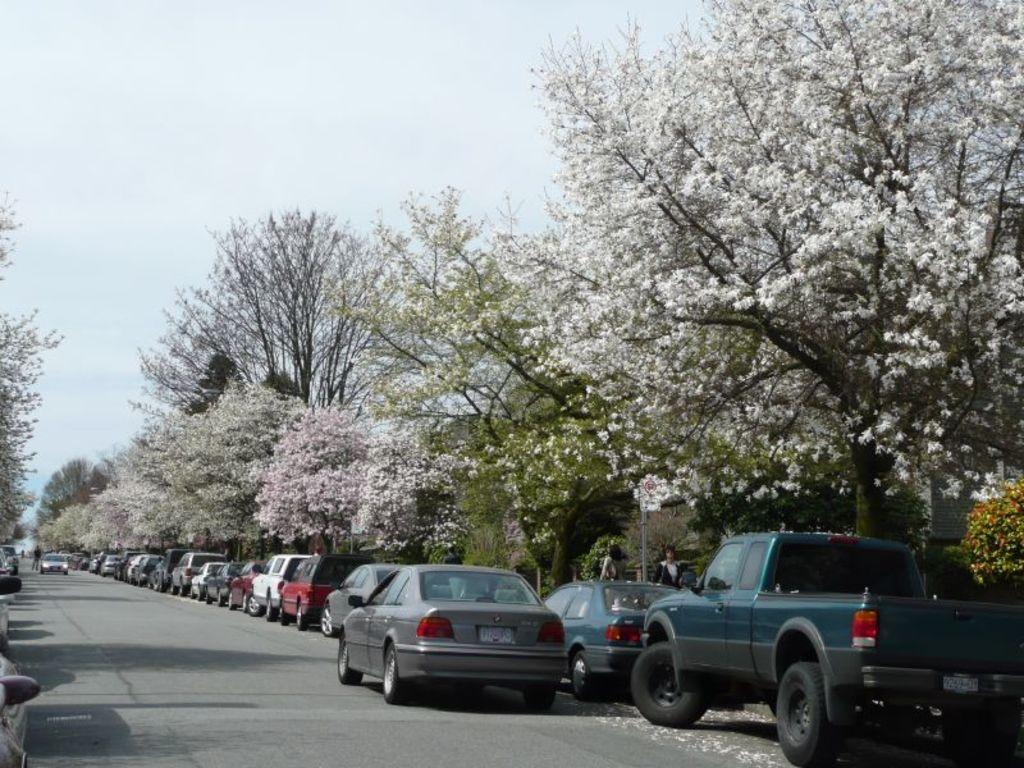What can be seen on the road in the image? There are vehicles on the road in the image. What type of vegetation is present in the image? There are trees with flowers in the image. Who or what is visible in the image besides the vehicles and trees? There are people visible in the image. What is visible at the top of the image? The sky is visible at the top of the image. What type of bait is being used by the people in the image? There is no mention of bait or fishing in the image; it features vehicles, trees, flowers, and people. Can you describe the twig that is being used as a design element in the image? There is no twig or design element mentioned in the image; it primarily features vehicles, trees, flowers, and people. 